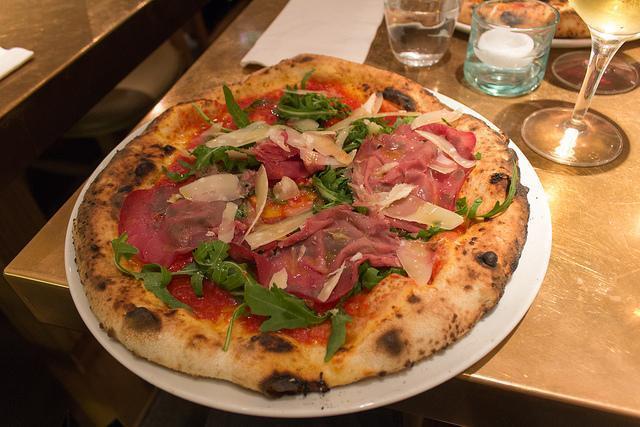How many plates are there?
Give a very brief answer. 1. How many pizzas are shown?
Give a very brief answer. 1. How many cups are there?
Give a very brief answer. 2. How many wine glasses are visible?
Give a very brief answer. 2. 